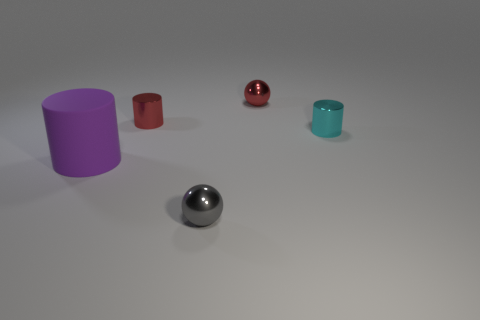Are there any other things that have the same material as the large purple object?
Give a very brief answer. No. Are there any other things that are the same size as the rubber cylinder?
Your response must be concise. No. What is the material of the tiny red object that is the same shape as the big purple rubber thing?
Your answer should be very brief. Metal. What number of other objects are there of the same size as the gray ball?
Make the answer very short. 3. Do the metal object that is in front of the cyan cylinder and the large purple thing have the same shape?
Provide a succinct answer. No. How many other things are the same shape as the purple object?
Give a very brief answer. 2. What is the shape of the object behind the red shiny cylinder?
Ensure brevity in your answer.  Sphere. Is there another red object made of the same material as the large object?
Provide a short and direct response. No. There is a shiny ball behind the red cylinder; does it have the same color as the large matte cylinder?
Make the answer very short. No. The matte cylinder has what size?
Make the answer very short. Large. 